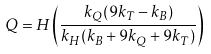Convert formula to latex. <formula><loc_0><loc_0><loc_500><loc_500>Q = H \left ( \frac { k _ { Q } ( 9 k _ { T } - k _ { B } ) } { k _ { H } ( k _ { B } + 9 k _ { Q } + 9 k _ { T } ) } \right )</formula> 